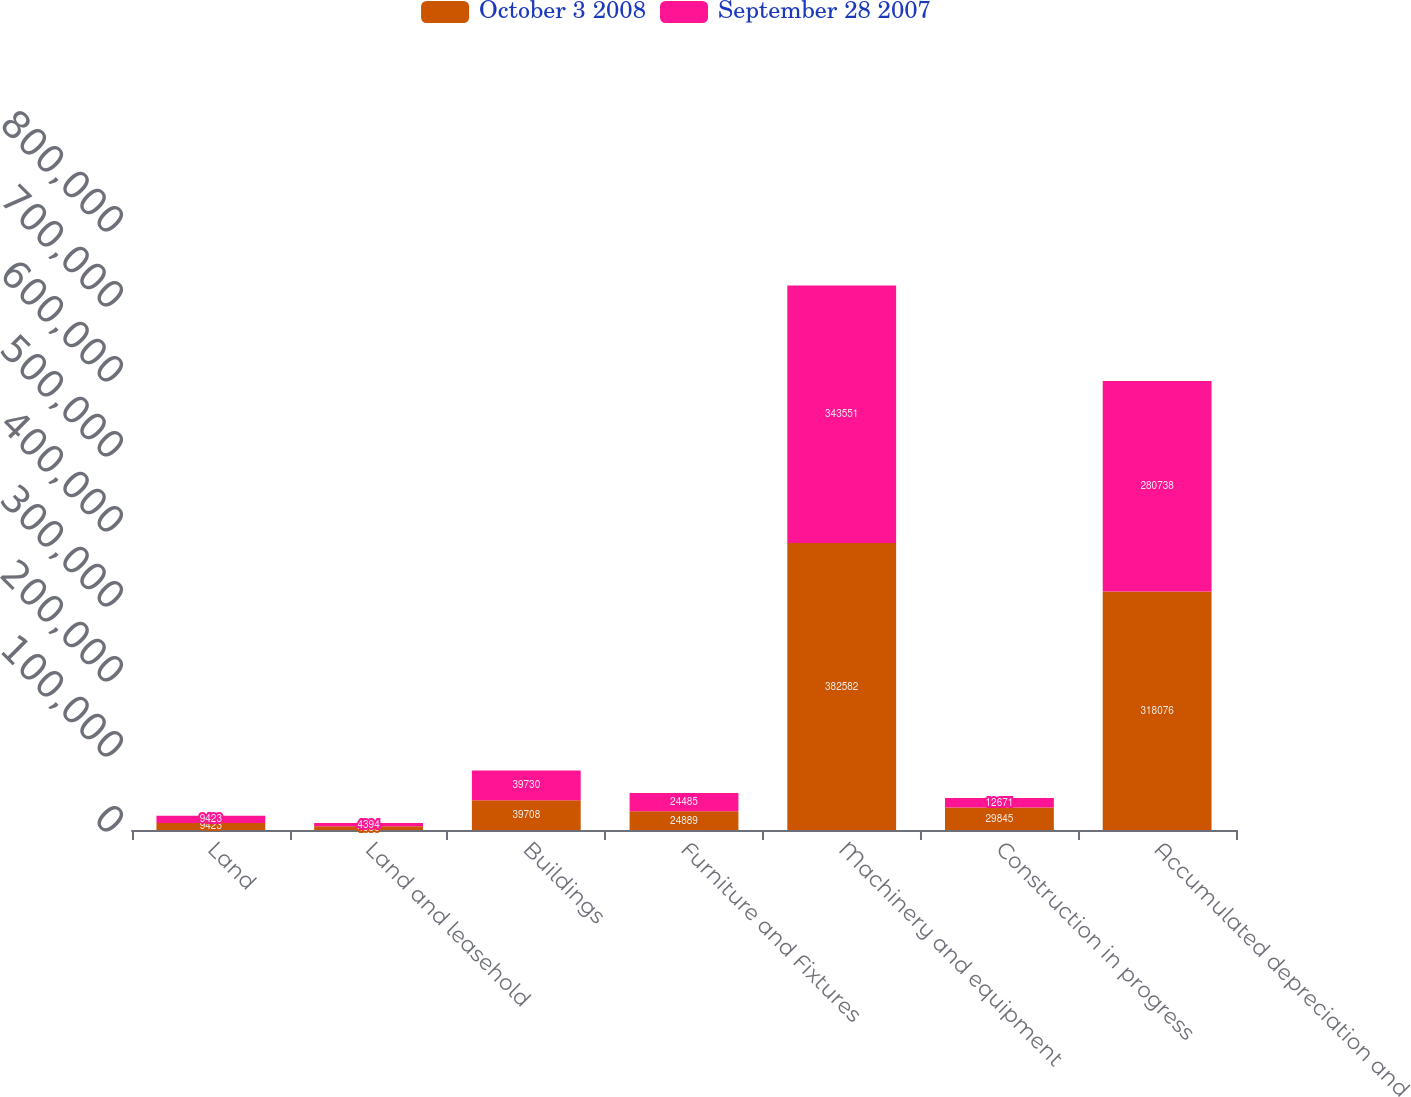<chart> <loc_0><loc_0><loc_500><loc_500><stacked_bar_chart><ecel><fcel>Land<fcel>Land and leasehold<fcel>Buildings<fcel>Furniture and Fixtures<fcel>Machinery and equipment<fcel>Construction in progress<fcel>Accumulated depreciation and<nl><fcel>October 3 2008<fcel>9423<fcel>4989<fcel>39708<fcel>24889<fcel>382582<fcel>29845<fcel>318076<nl><fcel>September 28 2007<fcel>9423<fcel>4394<fcel>39730<fcel>24485<fcel>343551<fcel>12671<fcel>280738<nl></chart> 